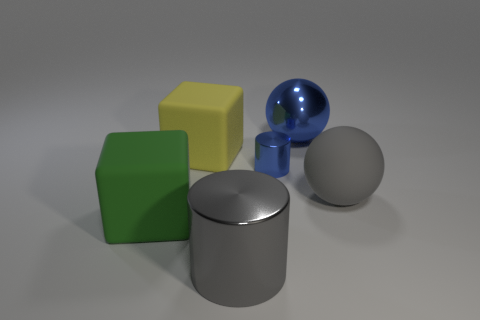Is there any other thing that is the same size as the blue metallic cylinder?
Offer a terse response. No. There is a ball that is the same color as the small cylinder; what is its size?
Provide a short and direct response. Large. The other thing that is the same shape as the large yellow object is what size?
Provide a succinct answer. Large. Is there anything else that has the same material as the gray cylinder?
Your answer should be compact. Yes. There is a sphere on the right side of the big metal thing that is behind the large green rubber object; are there any gray metallic cylinders behind it?
Keep it short and to the point. No. There is a block that is on the left side of the large yellow block; what is its material?
Your answer should be very brief. Rubber. What number of small things are blue matte cylinders or metallic balls?
Provide a succinct answer. 0. There is a rubber cube that is behind the green matte thing; is it the same size as the large metallic sphere?
Offer a very short reply. Yes. What number of other objects are the same color as the big cylinder?
Provide a short and direct response. 1. What is the material of the big blue sphere?
Provide a short and direct response. Metal. 